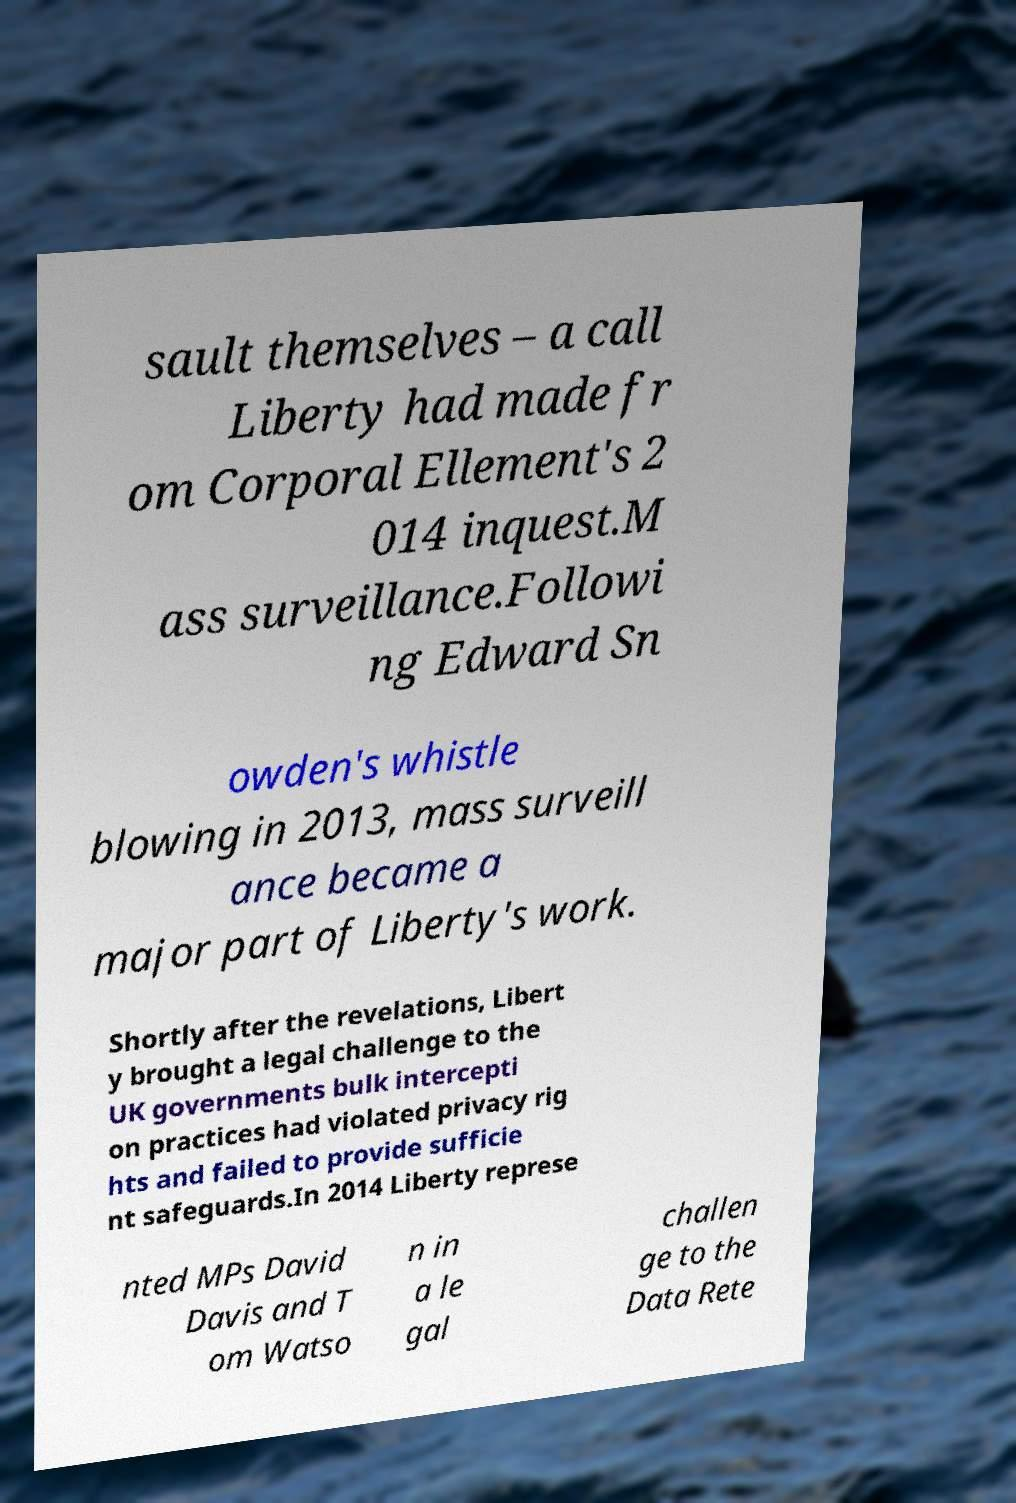Please read and relay the text visible in this image. What does it say? sault themselves – a call Liberty had made fr om Corporal Ellement's 2 014 inquest.M ass surveillance.Followi ng Edward Sn owden's whistle blowing in 2013, mass surveill ance became a major part of Liberty's work. Shortly after the revelations, Libert y brought a legal challenge to the UK governments bulk intercepti on practices had violated privacy rig hts and failed to provide sufficie nt safeguards.In 2014 Liberty represe nted MPs David Davis and T om Watso n in a le gal challen ge to the Data Rete 